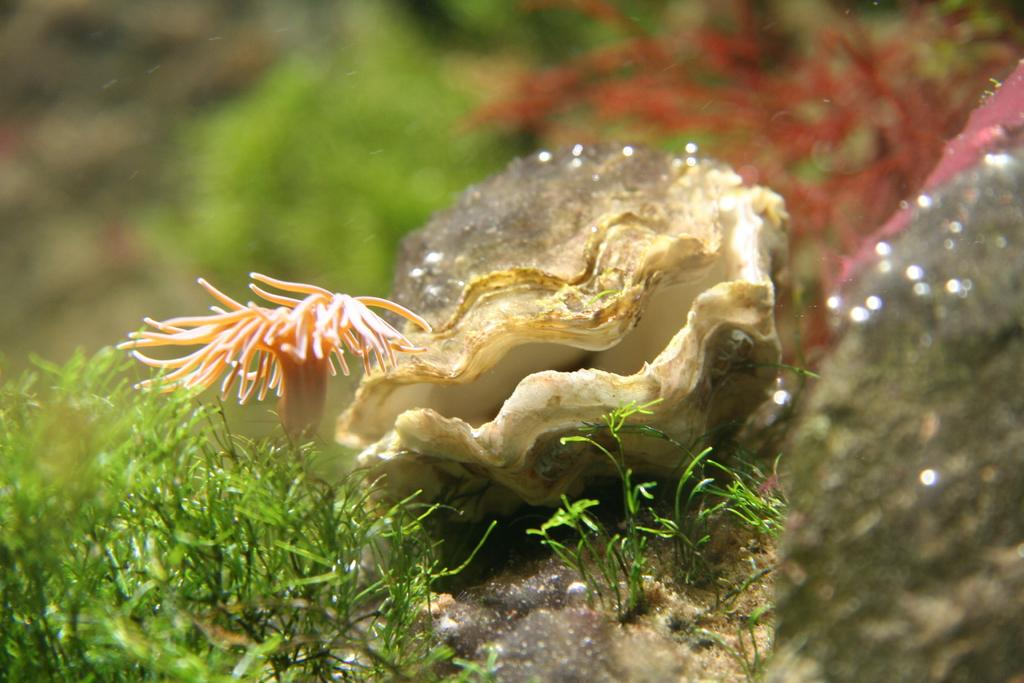What is the main object in the picture? There is a seashell in the picture. What other natural elements can be seen in the image? There are leaves and plants in the picture. How would you describe the background of the image? The background of the image is blurred. How many cats are involved in the battle depicted in the image? There are no cats or any battle present in the image; it features a seashell, leaves, and plants with a blurred background. 